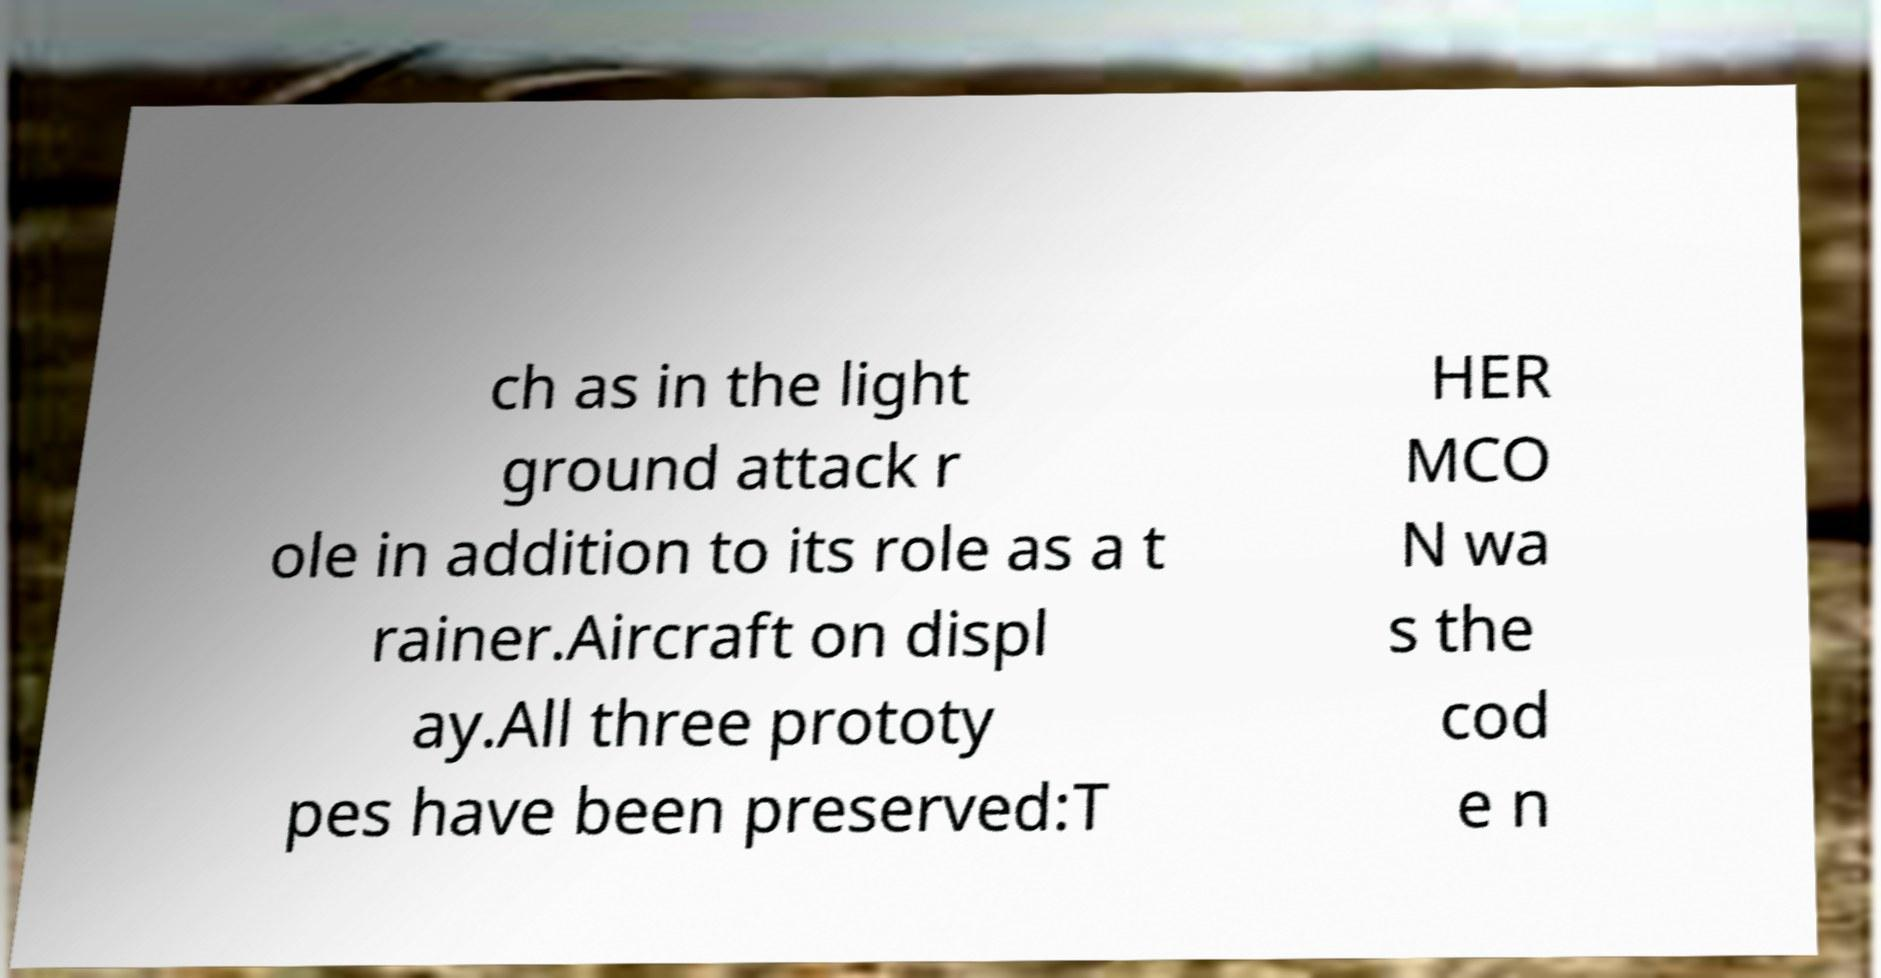Please read and relay the text visible in this image. What does it say? ch as in the light ground attack r ole in addition to its role as a t rainer.Aircraft on displ ay.All three prototy pes have been preserved:T HER MCO N wa s the cod e n 